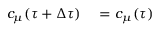Convert formula to latex. <formula><loc_0><loc_0><loc_500><loc_500>\begin{array} { r l } { c _ { \mu } ( \tau + \Delta \tau ) } & = c _ { \mu } ( \tau ) } \end{array}</formula> 